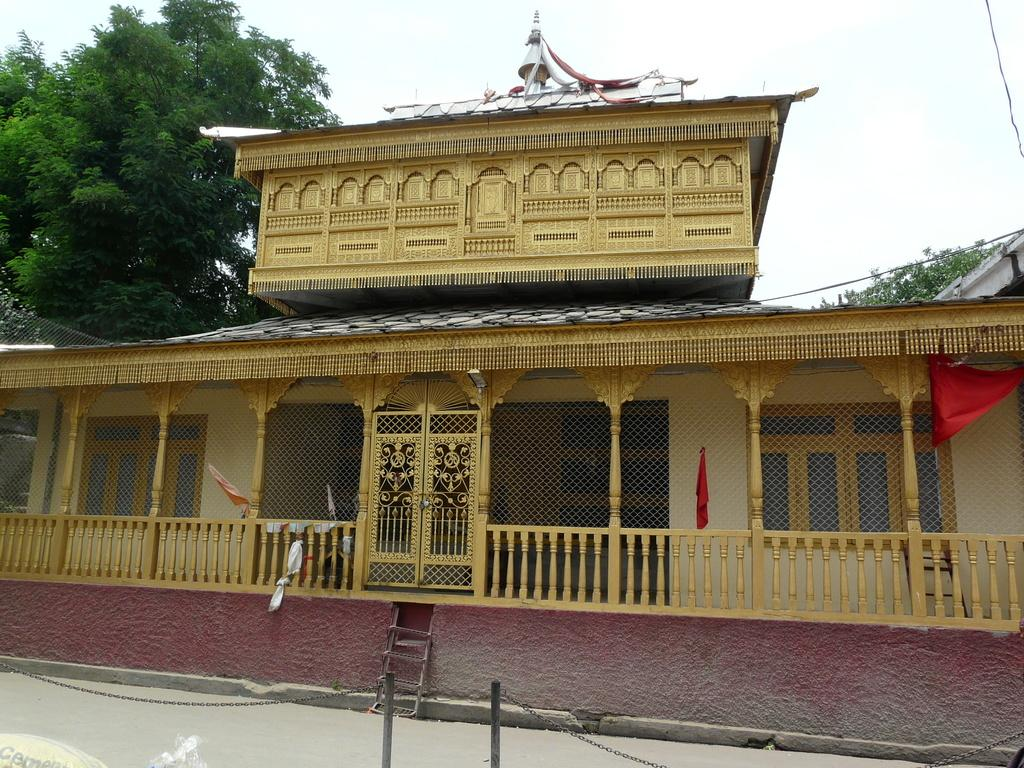What is the main subject in the center of the image? There is a shrine in the center of the image. What can be seen at the bottom side of the image? There is a boundary at the bottom side of the image. What type of natural scenery is visible in the background of the image? There are trees in the background of the image. What type of wave can be seen crashing against the shrine in the image? There is no wave present in the image; it features a shrine with a boundary and trees in the background. Is the governor present in the image? There is no mention of a governor or any political figure in the image. 